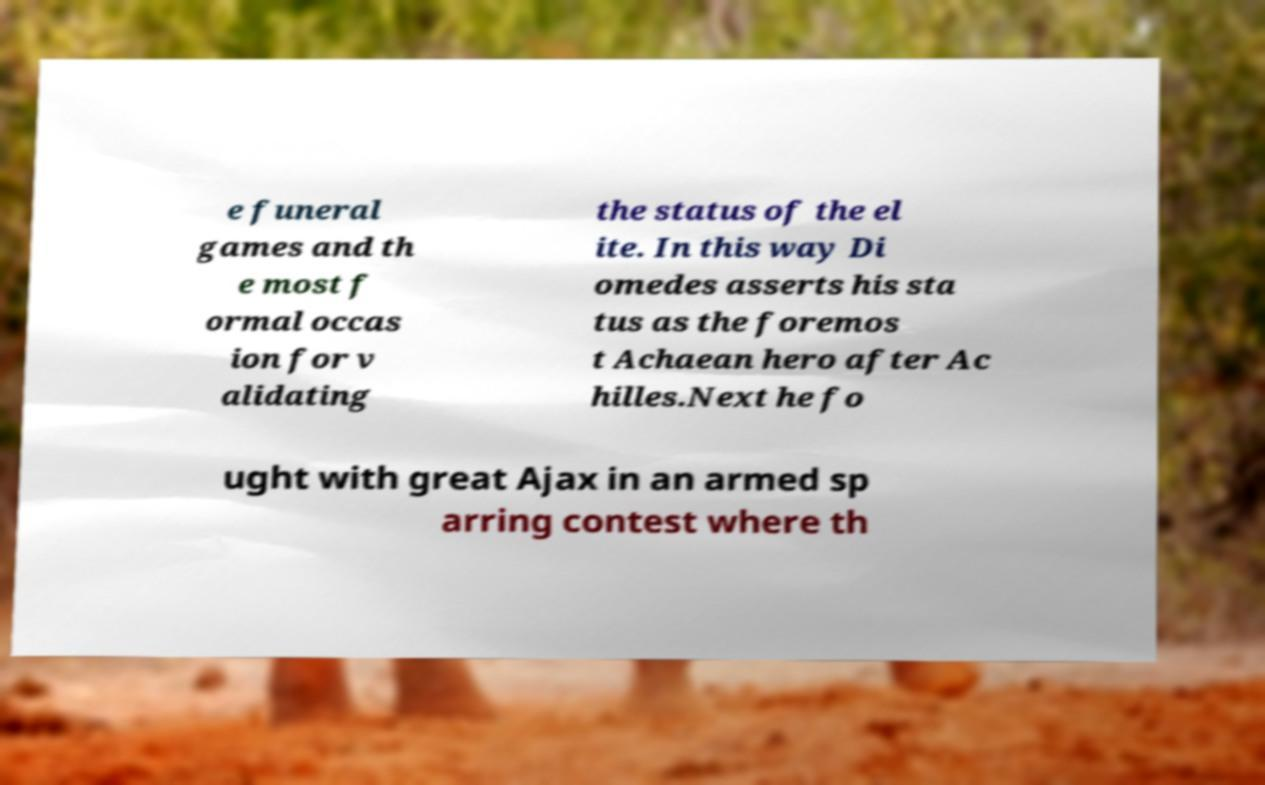Can you accurately transcribe the text from the provided image for me? e funeral games and th e most f ormal occas ion for v alidating the status of the el ite. In this way Di omedes asserts his sta tus as the foremos t Achaean hero after Ac hilles.Next he fo ught with great Ajax in an armed sp arring contest where th 